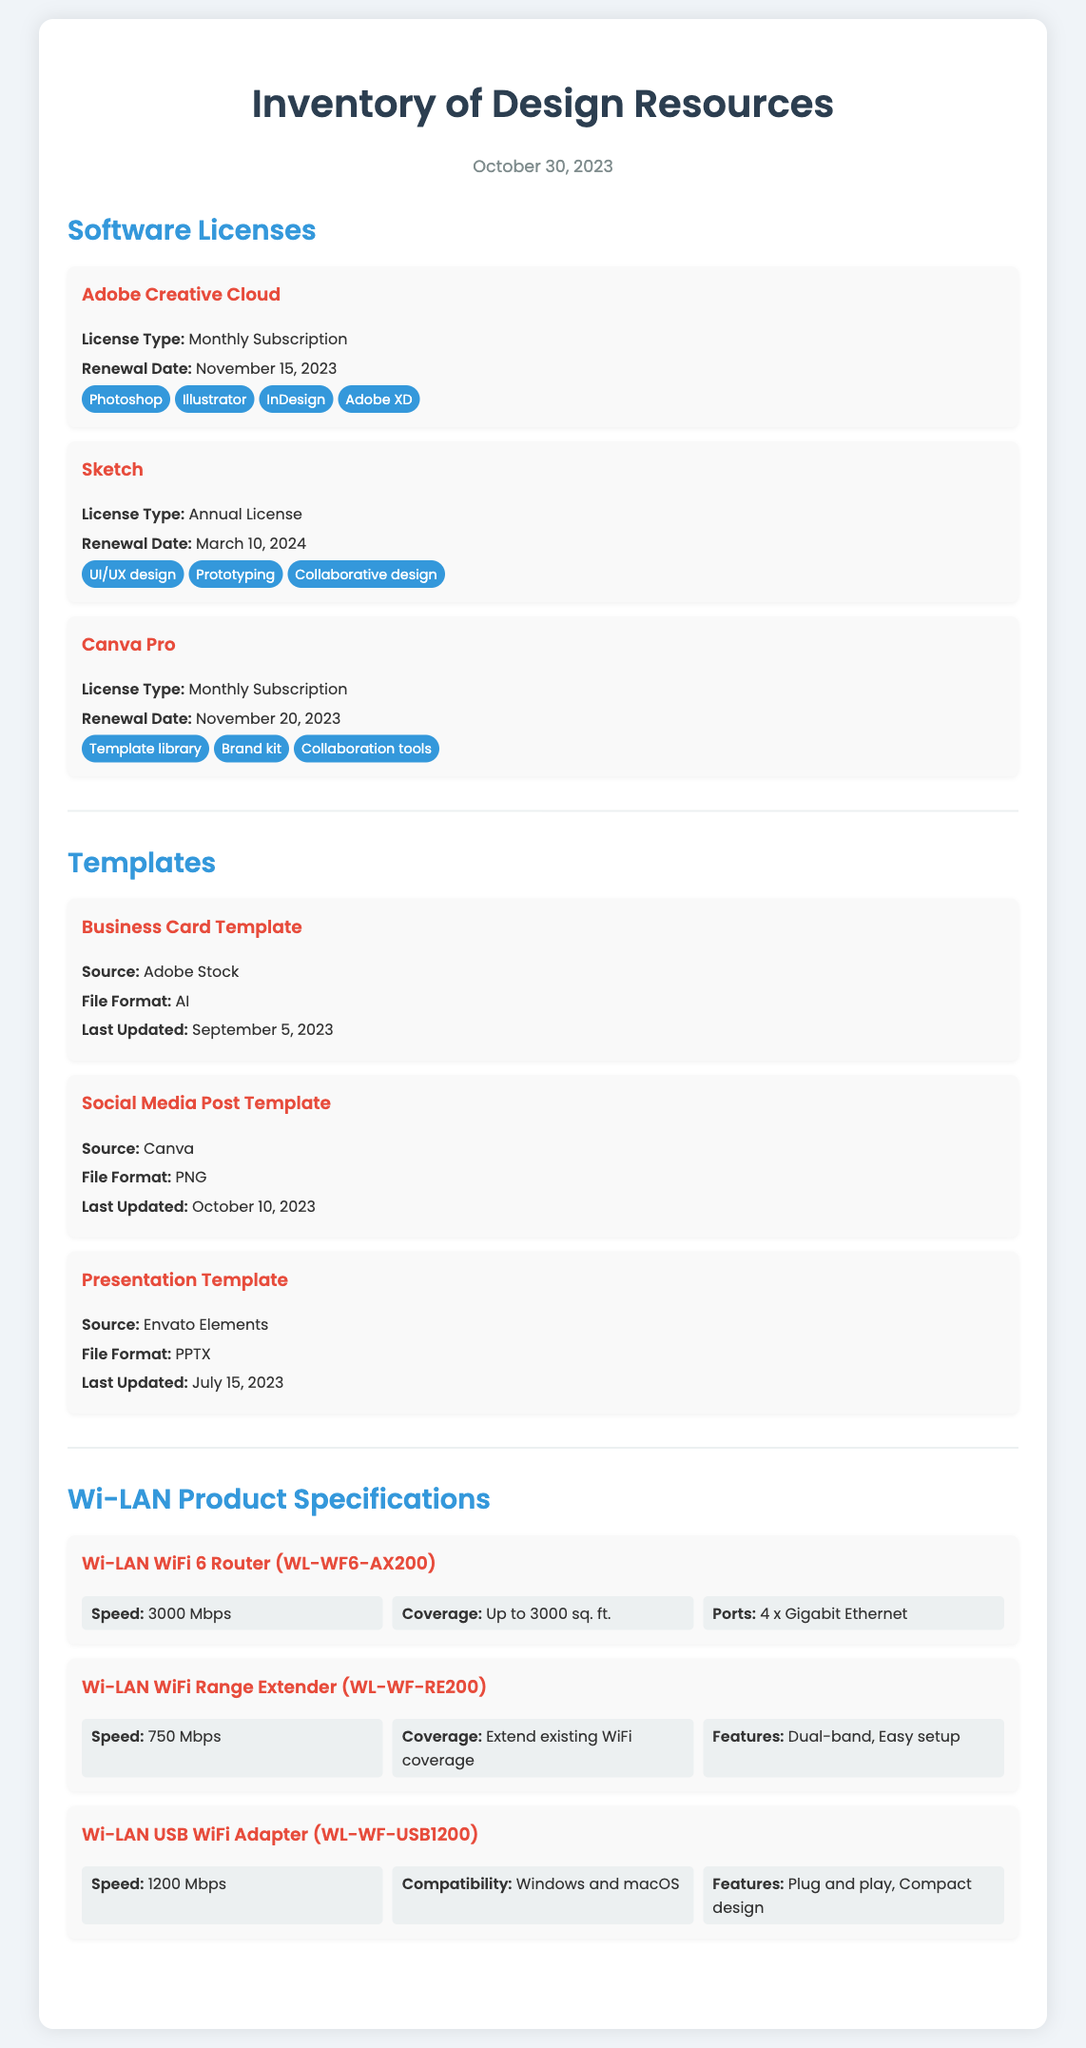What is the license type for Adobe Creative Cloud? The license type for Adobe Creative Cloud is explicitly mentioned in the document as "Monthly Subscription."
Answer: Monthly Subscription When is the renewal date for Canva Pro? The document states that the renewal date for Canva Pro is November 20, 2023.
Answer: November 20, 2023 What is the file format for the Presentation Template? The document lists "PPTX" as the file format for the Presentation Template.
Answer: PPTX What is the speed of the Wi-LAN WiFi 6 Router? The document specifies that the speed of the Wi-LAN WiFi 6 Router is "3000 Mbps."
Answer: 3000 Mbps Which design software has tools for collaborative design? The document lists "Sketch" as a design software that includes collaborative design tools.
Answer: Sketch What type of product is the Wi-LAN WL-WF-USB1200? The document identifies the "Wi-LAN USB WiFi Adapter" as the type of product for WL-WF-USB1200.
Answer: USB WiFi Adapter How many features are listed for the Wi-LAN WiFi Range Extender? The document provides three features for the Wi-LAN WiFi Range Extender: Dual-band, Easy setup, and Extend existing WiFi coverage.
Answer: Three features What source is listed for the Social Media Post Template? The document indicates that the source for the Social Media Post Template is "Canva."
Answer: Canva When was the Business Card Template last updated? According to the document, the Business Card Template was last updated on September 5, 2023.
Answer: September 5, 2023 